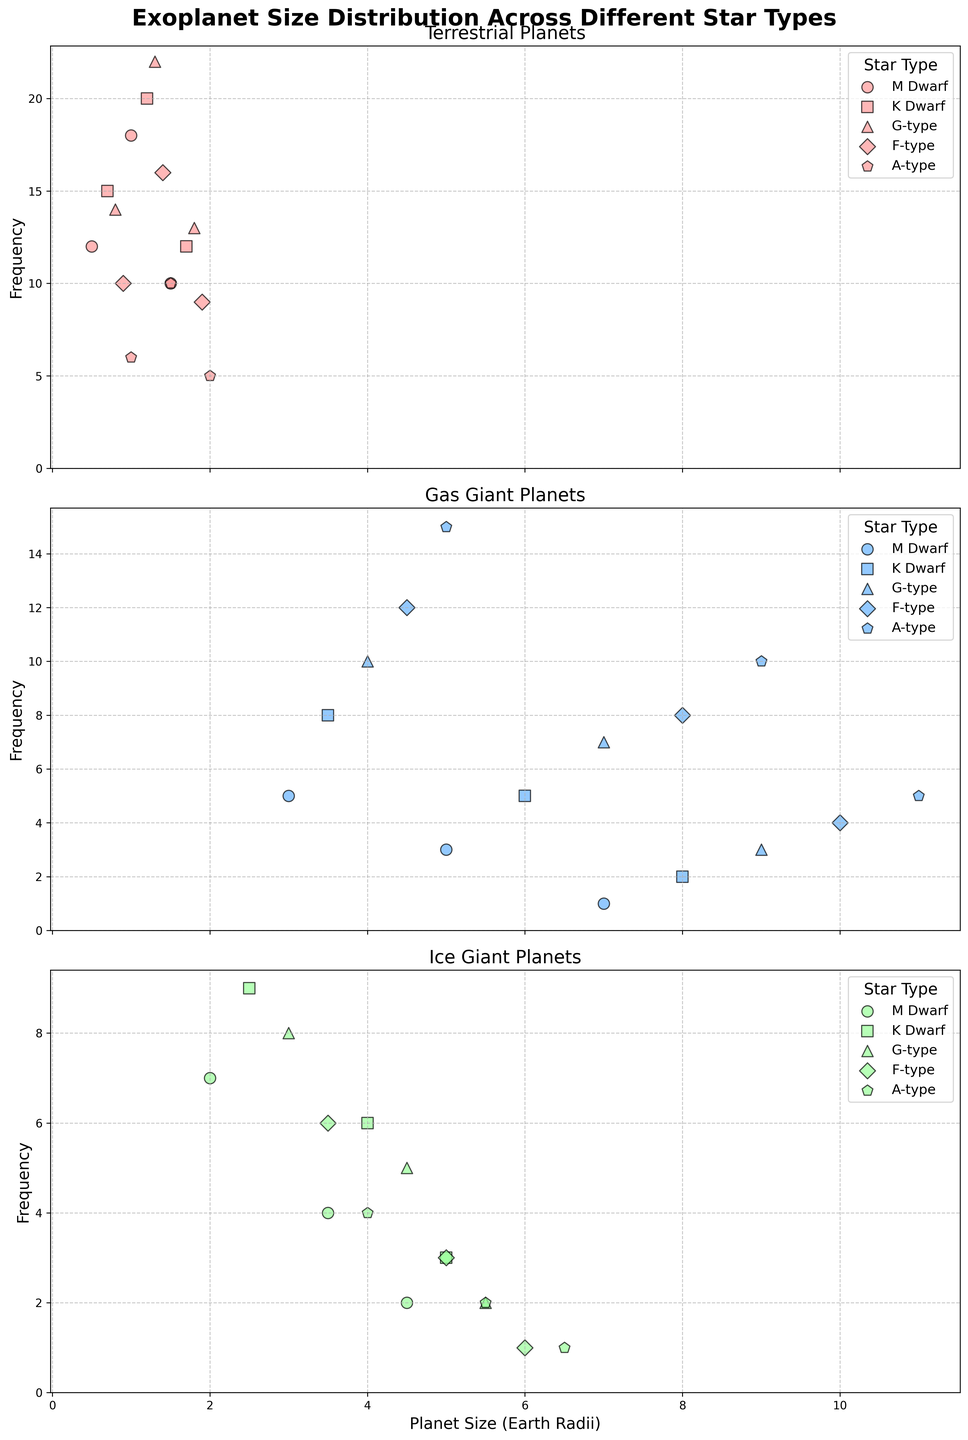Which star type has the highest frequency of terrestrial planets with a size of 1.0 Earth radii? Refer to the subplot for terrestrial planets and locate the point at 1.0 Earth radii. Find which star type has the highest frequency.
Answer: M Dwarf What is the difference in frequency between the terrestrial and gas giant planets of F-type stars? Check the subplots for both terrestrial and gas giant planets. For terrestrial planets, sum their frequencies: 10 + 16 + 9 = 35. For gas giants, sum their frequencies: 12 + 8 + 4 = 24. The difference is 35 - 24.
Answer: 11 Which planet type has the highest frequency overall for K Dwarf stars? Summarize the highest frequencies for each planet type within K Dwarf stars by examining all three subplots.
Answer: Terrestrial Are there more ice giants or gas giants larger than 4.0 Earth radii for A-type stars? Examine the subplots for ice giants and gas giants and count the frequencies for planets larger than 4.0 Earth radii for A-type stars. For ice giants: 4 + 2 + 1 = 7. For gas giants: 10 + 5 = 15.
Answer: Gas Giants How many terrestrial planets larger than 1.5 Earth radii are there around G-type stars? Look at the subplot for terrestrial planets and sum the frequencies for G-type stars at sizes larger than 1.5 Earth radii: 13.
Answer: 13 Which star type has the least frequent gas giant planets with a size of 5.0 Earth radii? Refer to the subplot for gas giant planets and find the frequency at 5.0 Earth radii for each star type.
Answer: M Dwarf Between terrestrial planets of 0.5 Earth radii and 1.2 Earth radii for M Dwarf and K Dwarf stars, which combination has the highest frequency? For M Dwarf: 0.5 Earth radii (12) and for K Dwarf: 1.2 Earth radii (20). Highest frequency is 20.
Answer: 1.2 Earth radii (K Dwarf) What is the total frequency of ice giants across all star types? Sum the frequencies of all data points for ice giants across M Dwarf, K Dwarf, G-type, F-type, and A-type stars.
Answer: 65 Which type of planet size is more frequent among A-type stars: 5.0 Earth radii gas giants or 5.0 Earth radii ice giants? Compare the frequency values of 5.0 Earth radii for gas giants and ice giants in A-type stars subplot. Gas giants: 15. Ice giants: 2.
Answer: Gas Giants Do F-type stars have more terrestrial planets at 1.4 Earth radii or gas giants at 8.0 Earth radii? Check the frequencies of F-type stars for planets at 1.4 Earth radii (terrestrial) and 8.0 Earth radii (gas giants).
Answer: Terrestrial at 1.4 Earth radii 